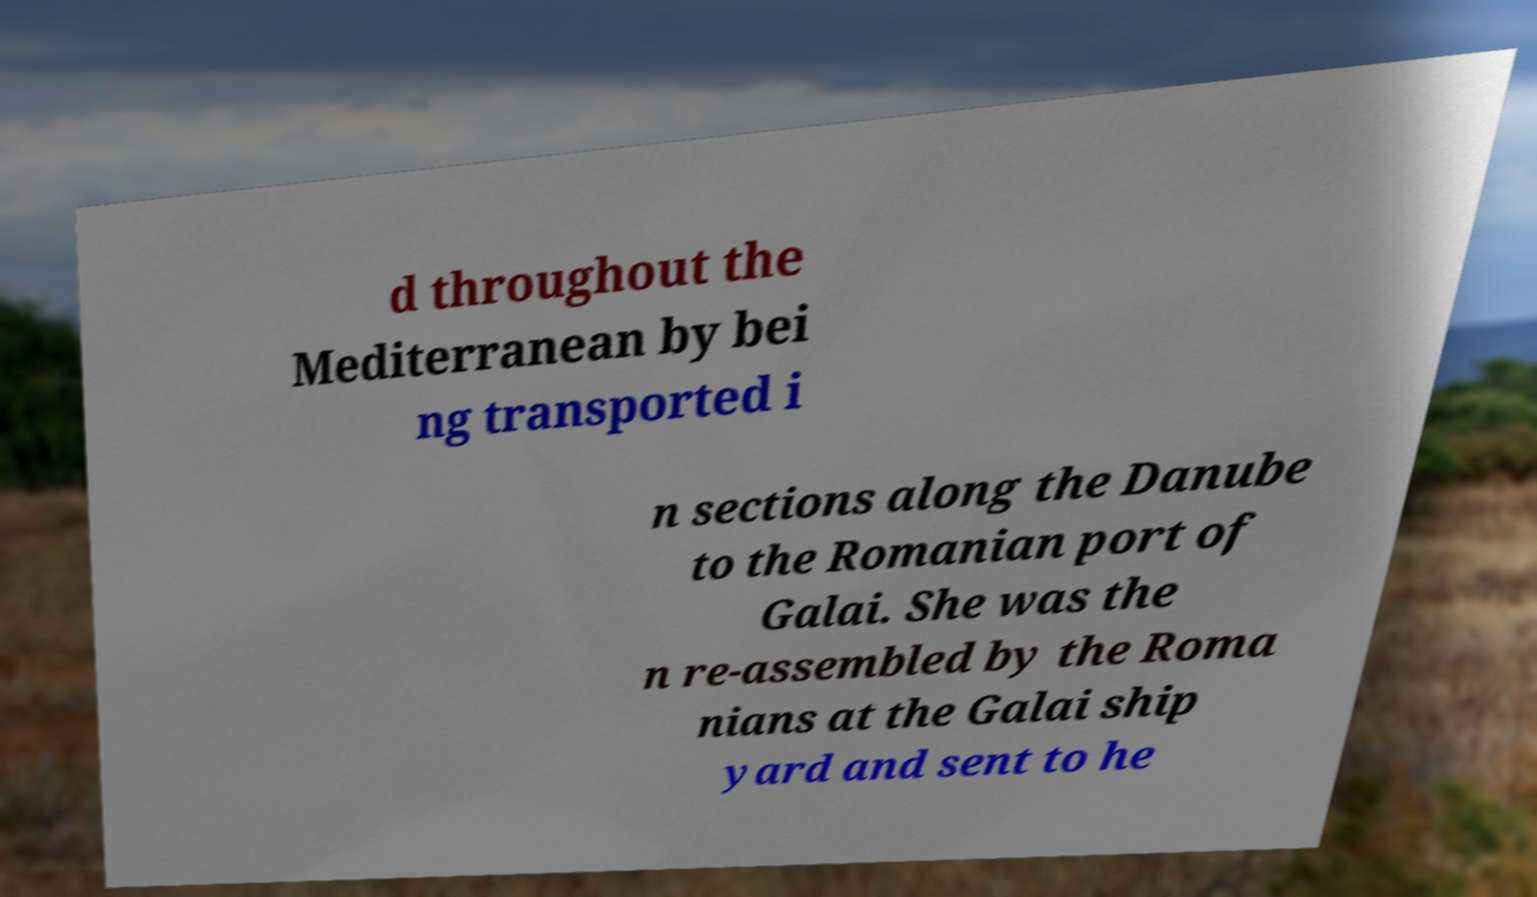I need the written content from this picture converted into text. Can you do that? d throughout the Mediterranean by bei ng transported i n sections along the Danube to the Romanian port of Galai. She was the n re-assembled by the Roma nians at the Galai ship yard and sent to he 